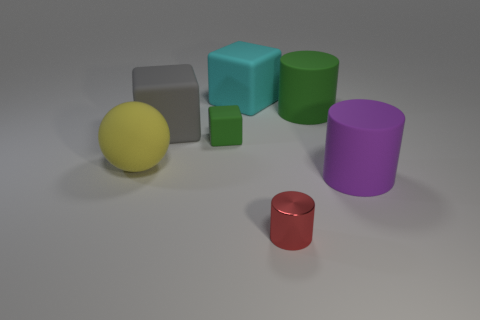Is there anything else that is the same shape as the big yellow object?
Give a very brief answer. No. Are there an equal number of rubber cylinders that are left of the purple cylinder and blue things?
Offer a very short reply. No. What number of large purple things are the same shape as the yellow rubber thing?
Make the answer very short. 0. Do the purple matte object and the metallic object have the same shape?
Provide a succinct answer. Yes. What number of objects are either cylinders behind the small red shiny thing or tiny matte cubes?
Offer a terse response. 3. What shape is the rubber object to the right of the large matte cylinder behind the big purple matte cylinder right of the large green cylinder?
Provide a succinct answer. Cylinder. There is a large green thing that is made of the same material as the large cyan block; what is its shape?
Keep it short and to the point. Cylinder. The purple cylinder has what size?
Your answer should be compact. Large. Do the yellow sphere and the purple matte thing have the same size?
Offer a terse response. Yes. What number of objects are red shiny cylinders that are in front of the big gray object or cyan rubber things that are left of the tiny shiny object?
Give a very brief answer. 2. 